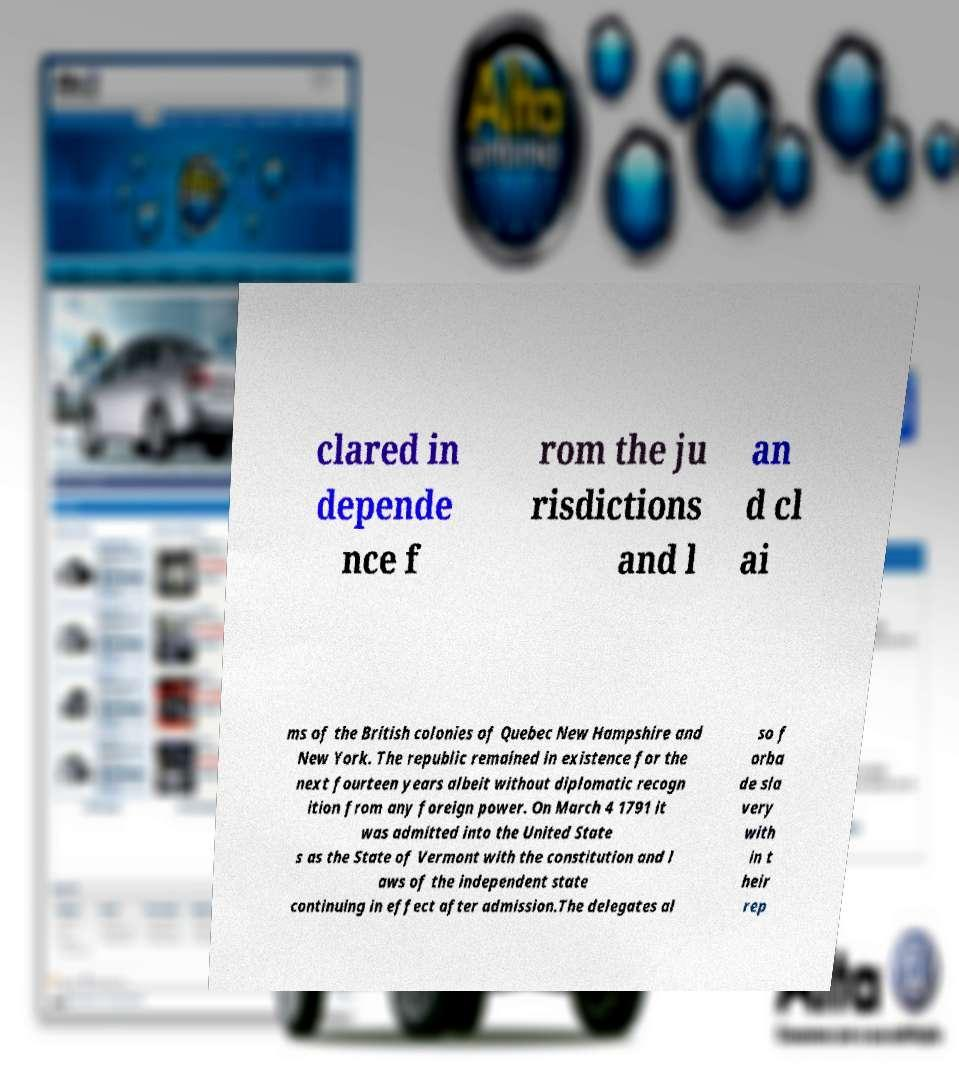Can you read and provide the text displayed in the image?This photo seems to have some interesting text. Can you extract and type it out for me? clared in depende nce f rom the ju risdictions and l an d cl ai ms of the British colonies of Quebec New Hampshire and New York. The republic remained in existence for the next fourteen years albeit without diplomatic recogn ition from any foreign power. On March 4 1791 it was admitted into the United State s as the State of Vermont with the constitution and l aws of the independent state continuing in effect after admission.The delegates al so f orba de sla very with in t heir rep 